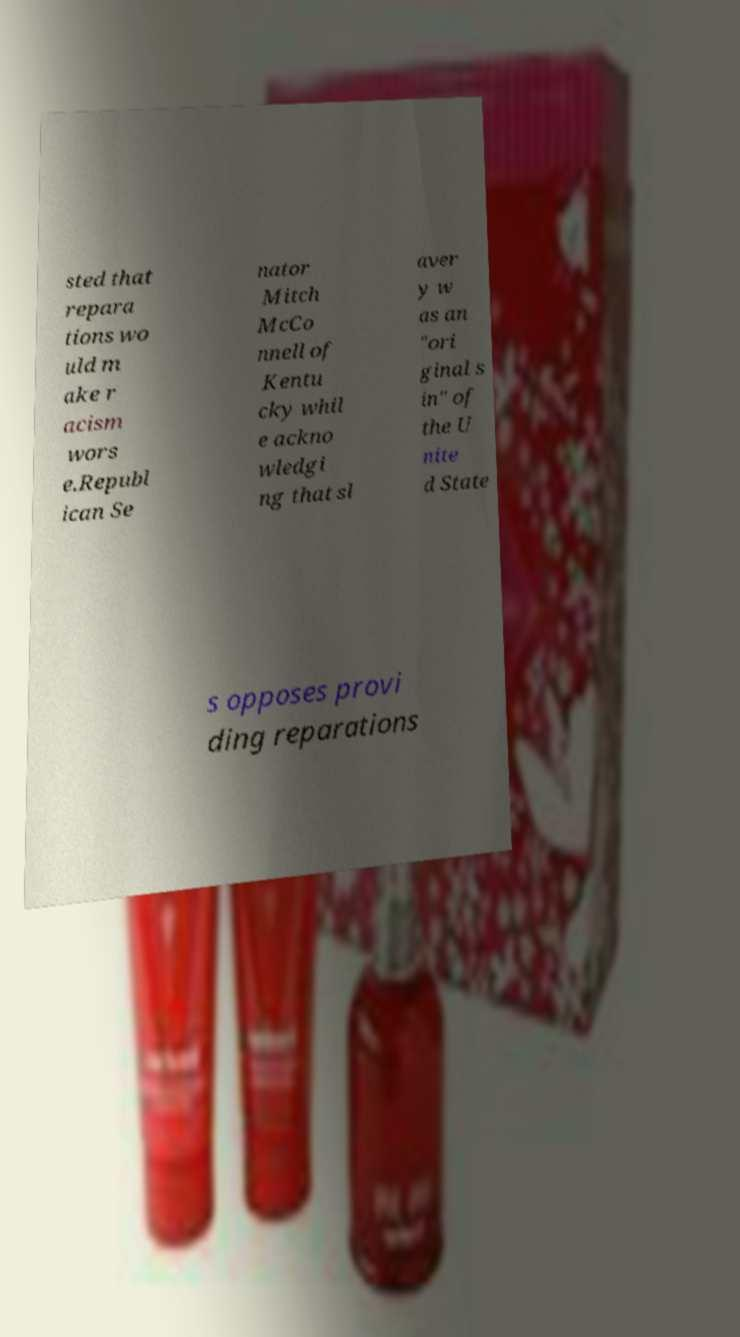I need the written content from this picture converted into text. Can you do that? sted that repara tions wo uld m ake r acism wors e.Republ ican Se nator Mitch McCo nnell of Kentu cky whil e ackno wledgi ng that sl aver y w as an "ori ginal s in" of the U nite d State s opposes provi ding reparations 